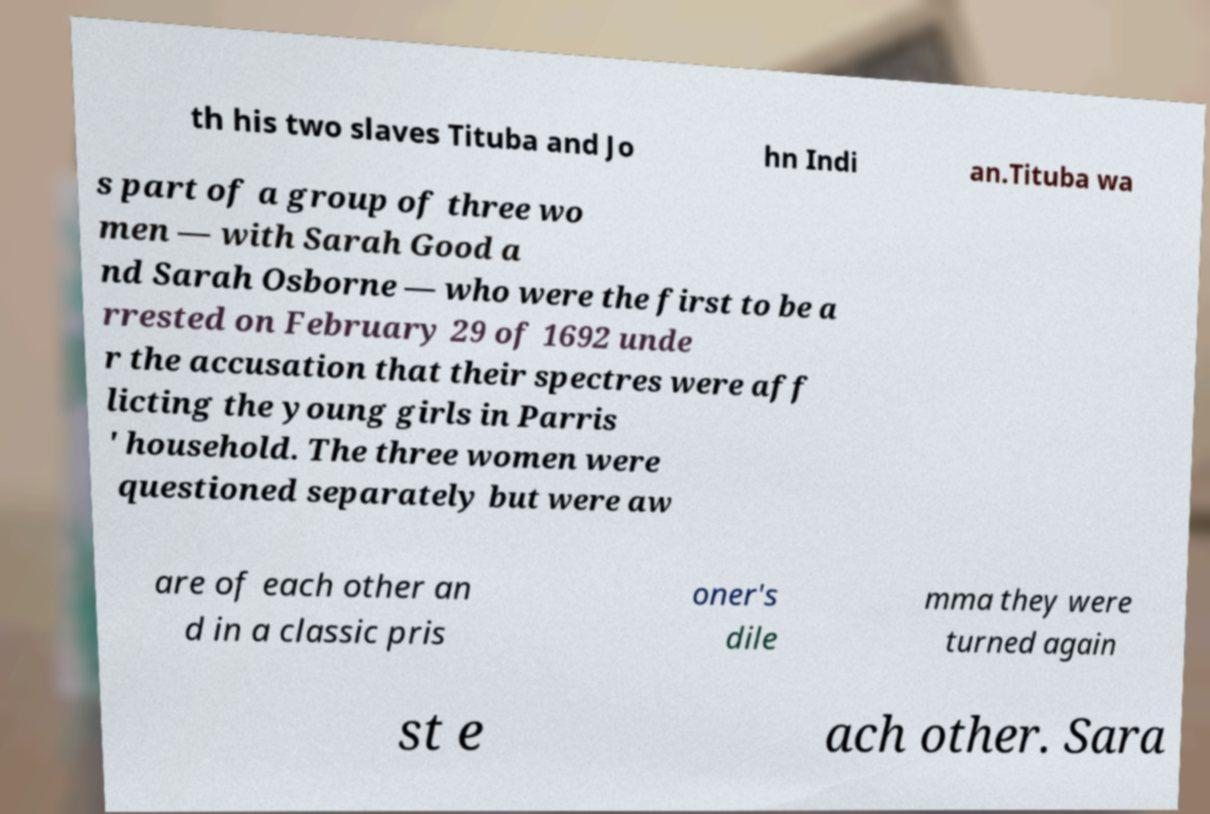Can you read and provide the text displayed in the image?This photo seems to have some interesting text. Can you extract and type it out for me? th his two slaves Tituba and Jo hn Indi an.Tituba wa s part of a group of three wo men — with Sarah Good a nd Sarah Osborne — who were the first to be a rrested on February 29 of 1692 unde r the accusation that their spectres were aff licting the young girls in Parris ' household. The three women were questioned separately but were aw are of each other an d in a classic pris oner's dile mma they were turned again st e ach other. Sara 